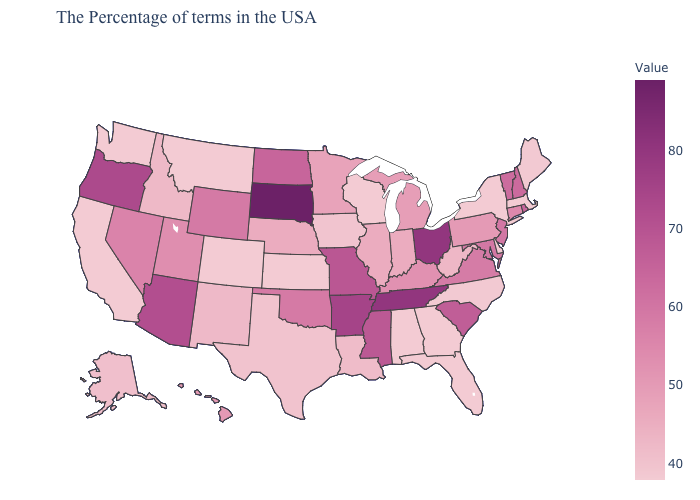Among the states that border Arizona , which have the highest value?
Quick response, please. Nevada. Which states hav the highest value in the West?
Answer briefly. Oregon. Is the legend a continuous bar?
Concise answer only. Yes. Among the states that border Arizona , which have the highest value?
Answer briefly. Nevada. Which states have the lowest value in the West?
Be succinct. Colorado, Montana, California, Washington. 